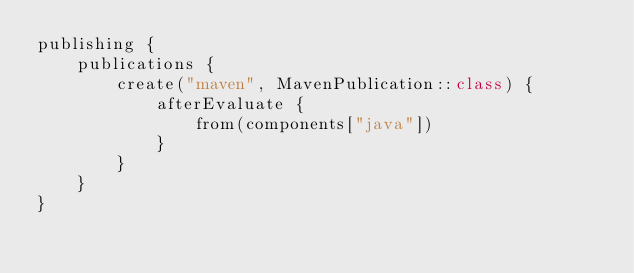Convert code to text. <code><loc_0><loc_0><loc_500><loc_500><_Kotlin_>publishing {
    publications {
        create("maven", MavenPublication::class) {
            afterEvaluate {
                from(components["java"])
            }
        }
    }
}
</code> 